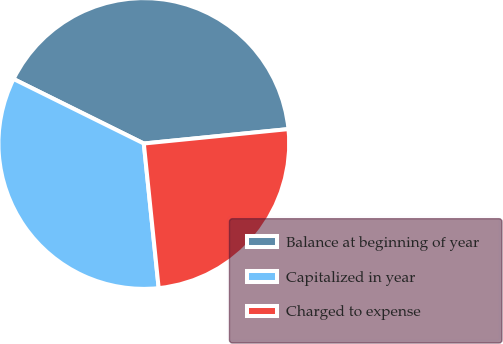<chart> <loc_0><loc_0><loc_500><loc_500><pie_chart><fcel>Balance at beginning of year<fcel>Capitalized in year<fcel>Charged to expense<nl><fcel>41.1%<fcel>33.95%<fcel>24.95%<nl></chart> 